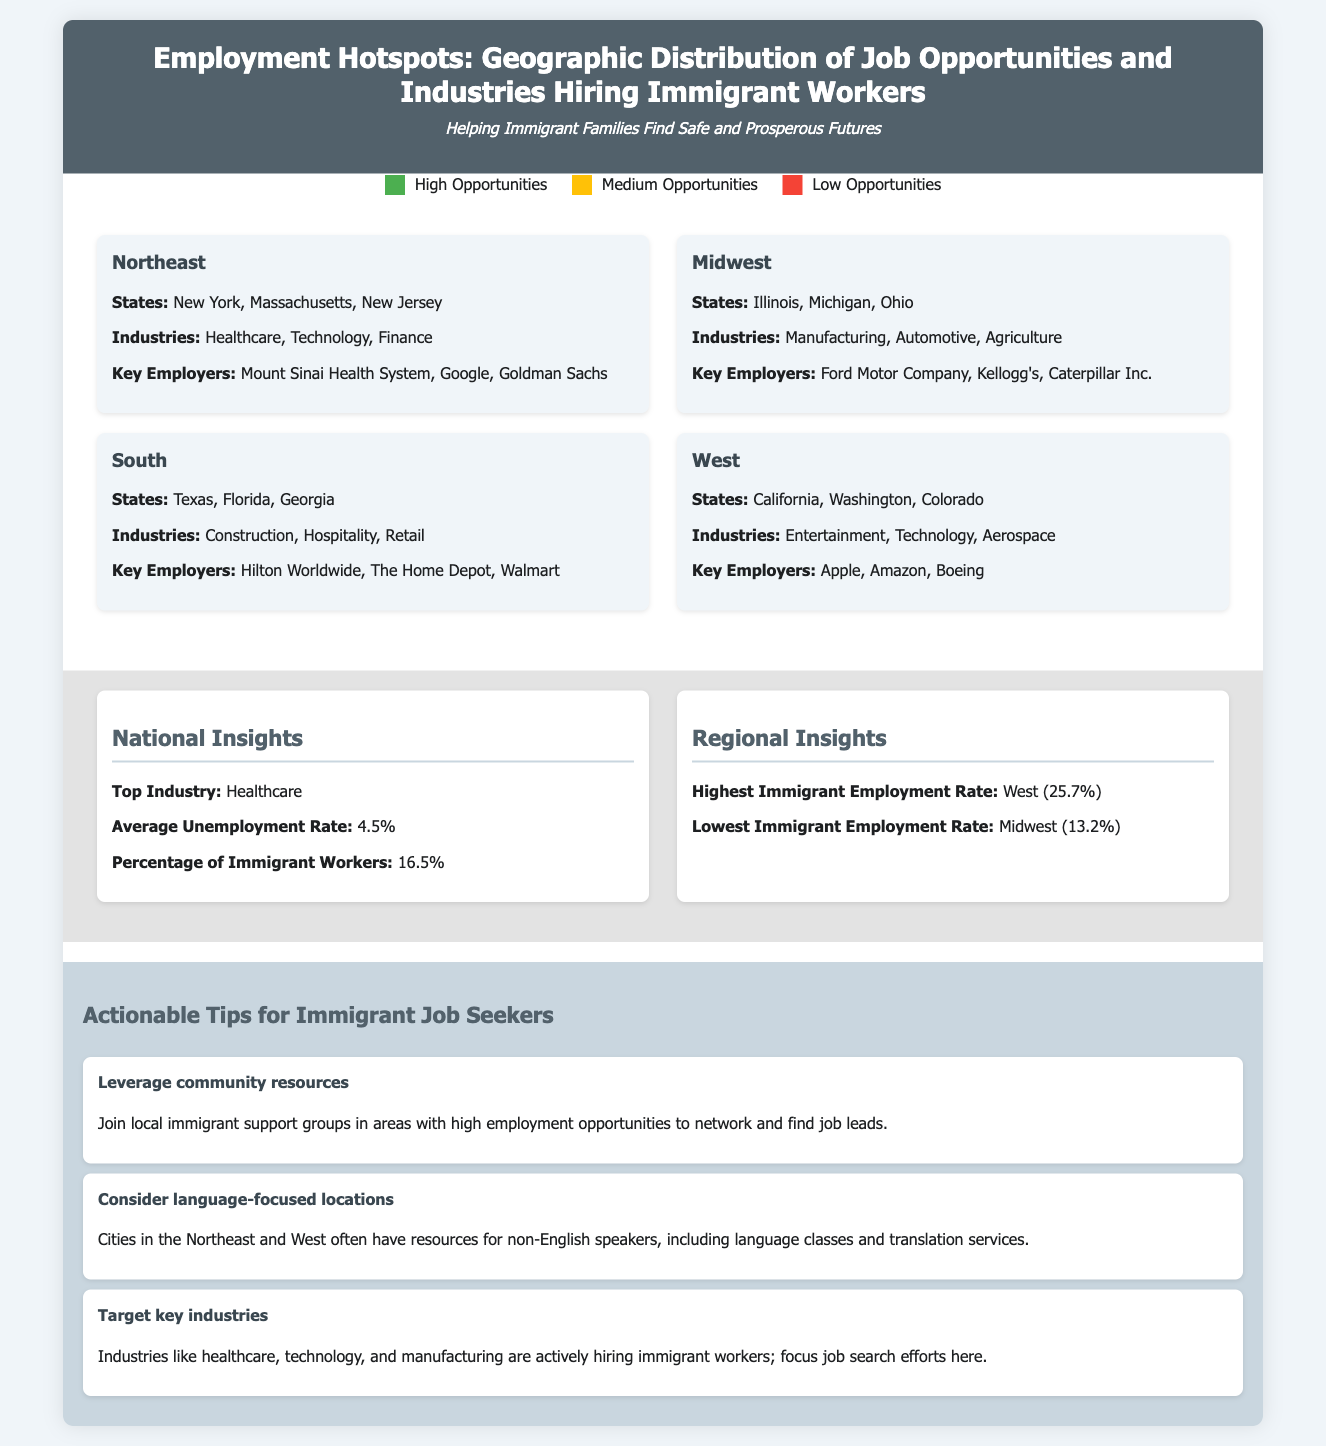What are the primary industries hiring in the Northeast? The document lists "Healthcare, Technology, Finance" as the primary industries in the Northeast region.
Answer: Healthcare, Technology, Finance Which region has the highest immigrant employment rate? The document highlights that the West region has the highest immigrant employment rate at 25.7%.
Answer: West (25.7%) What states are included in the South region? The South region includes the states of Texas, Florida, and Georgia according to the document.
Answer: Texas, Florida, Georgia What is the average unemployment rate mentioned? The document states that the average unemployment rate is 4.5%.
Answer: 4.5% Which key employer is associated with the Midwest? "Ford Motor Company" is noted as a key employer in the Midwest region of the document.
Answer: Ford Motor Company What is the percentage of immigrant workers nationally? According to the document, the percentage of immigrant workers is 16.5%.
Answer: 16.5% What actionable tip focuses on community support? The tip "Leverage community resources" emphasizes joining local immigrant support groups for networking.
Answer: Leverage community resources What color represents high job opportunities in the legend? The color green is used in the legend to represent high job opportunities.
Answer: Green Which industry is identified as the top industry in the national insights? The document identifies "Healthcare" as the top industry in the national insights section.
Answer: Healthcare 